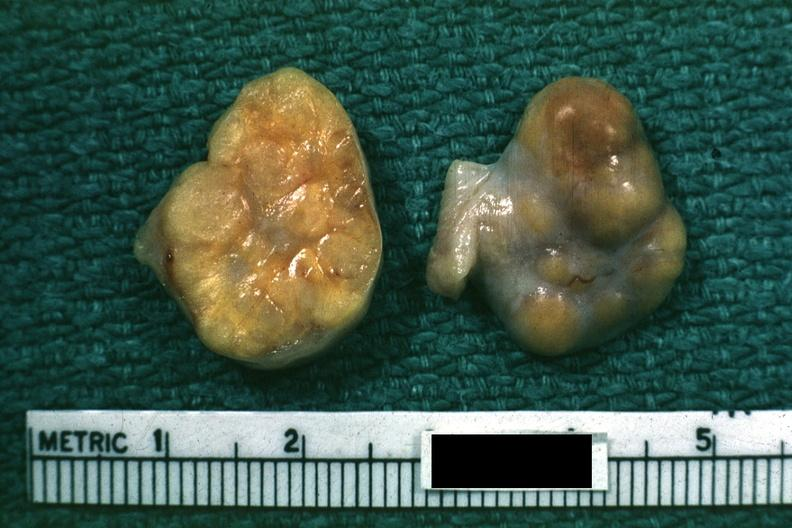s ovary present?
Answer the question using a single word or phrase. Yes 